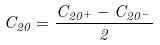<formula> <loc_0><loc_0><loc_500><loc_500>C _ { 2 0 } = \frac { C _ { 2 0 ^ { + } } - C _ { 2 0 ^ { - } } } { 2 }</formula> 